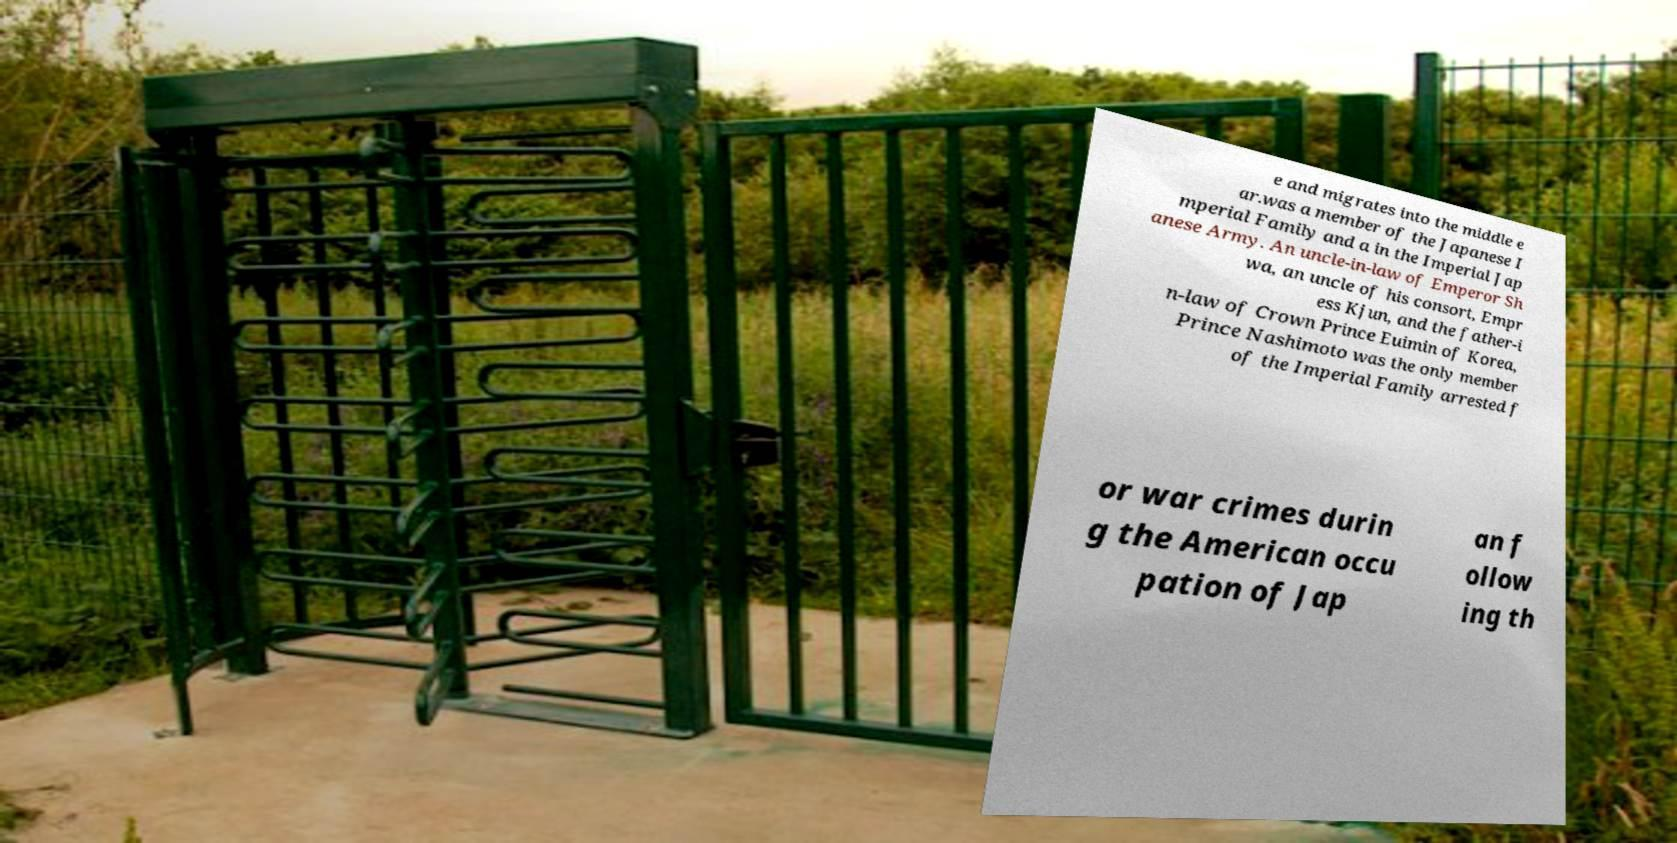For documentation purposes, I need the text within this image transcribed. Could you provide that? e and migrates into the middle e ar.was a member of the Japanese I mperial Family and a in the Imperial Jap anese Army. An uncle-in-law of Emperor Sh wa, an uncle of his consort, Empr ess Kjun, and the father-i n-law of Crown Prince Euimin of Korea, Prince Nashimoto was the only member of the Imperial Family arrested f or war crimes durin g the American occu pation of Jap an f ollow ing th 